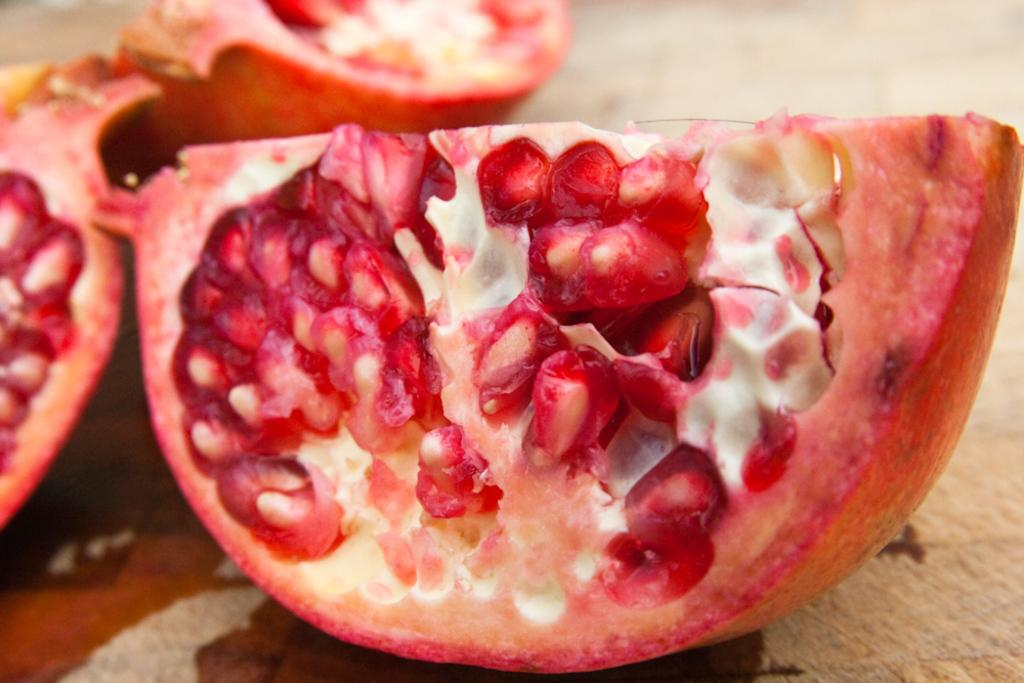What type of fruit is visible in the image? There are pieces of pomegranates in the image. What type of air is being used to solve the riddle in the image? There is no riddle or air present in the image; it only features pieces of pomegranates. How many feet are visible in the image? There are no feet visible in the image; it only features pieces of pomegranates. 